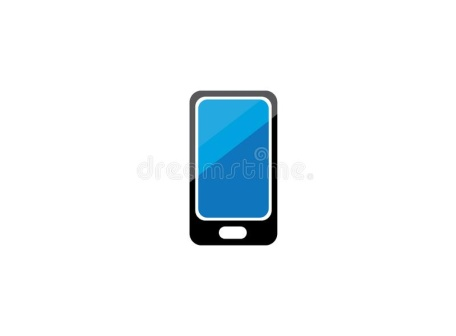What would this phone be like in a medieval fantasy setting? In a medieval fantasy setting, this phone could be seen as a magical artifact, crafted by ancient wizards. The sleek black casing would be embedded with runes that shimmer with a radiant blue light, indicating powerful enchantments. It would serve as a magical communicator, allowing the user to send messages through ethereal realms and summon spirits for guidance. The blue screen could display mystical symbols, enabling the user to cast spells and enchantments by tracing patterns on its surface. When used in conjunction with other magical artifacts, it could enhance their powers, allowing its possessor to perform feats like invisibility, teleportation, or controlling the elements. Its home button might be a talisman that grants the user protection against dark magic. In the medieval kingdom of Eldoria, an ancient artifact lay hidden in the ruins of a forgotten tower. Legend spoke of its powers to communicate across vast distances, a relic left by the first wizards. One day, a young squire named Eamon stumbled upon this artifact, a sleek black device with a glowing blue screen. Unaware of its true nature, he took it to the wizard Maelis. The wise wizard recognized its potential immediately – the device’s runes shimmered with magic as he examined it. As Eamon held the device, it activated, displaying a map leading to the hidden chambers of the dragon lord, Draconis. With the artifact's guidance, Eamon and Maelis journeyed through treacherous lands, the device illuminating their path and unlocking ancient spells at every step. In the final showdown with Draconis, the device granted Eamon the power to channel his inner strength, ultimately bringing peace to Eldoria. The phone, revered as the 'Crystal Conclave,' became a symbol of hope and unity in the kingdom. 